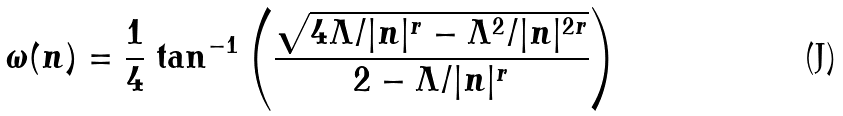<formula> <loc_0><loc_0><loc_500><loc_500>\omega ( n ) = \frac { 1 } { 4 } \ { \tan ^ { - 1 } \left ( \frac { \sqrt { 4 \Lambda / | n | ^ { r } - \Lambda ^ { 2 } / | n | ^ { 2 r } } } { 2 - \Lambda / | n | ^ { r } } \right ) }</formula> 